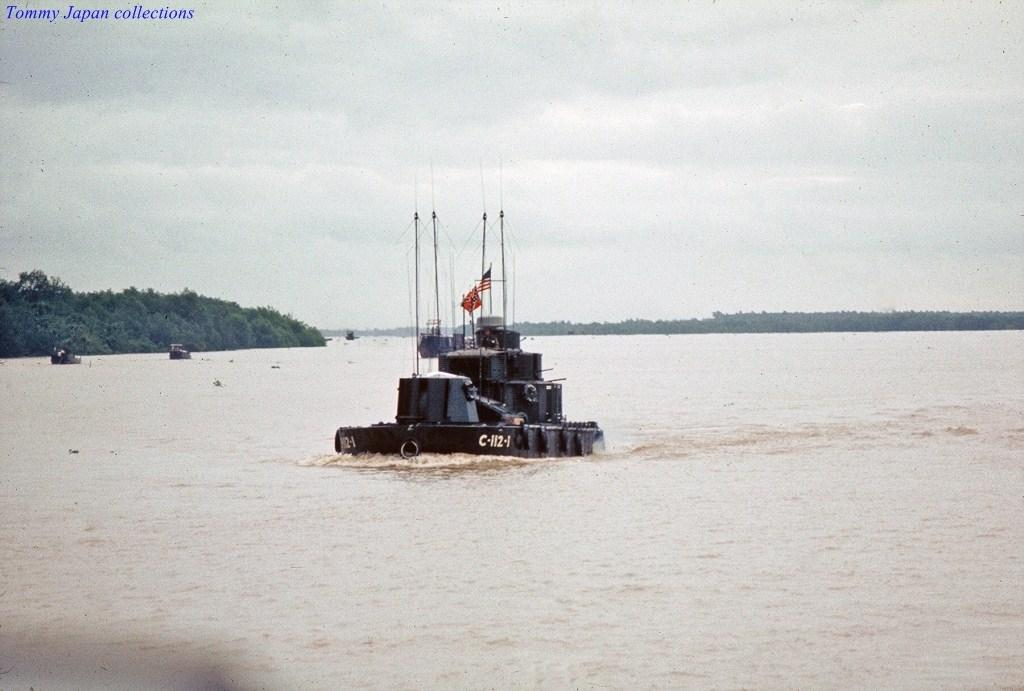<image>
Create a compact narrative representing the image presented. A boat with C-112-1 written on the side of it. 